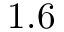Convert formula to latex. <formula><loc_0><loc_0><loc_500><loc_500>1 . 6</formula> 